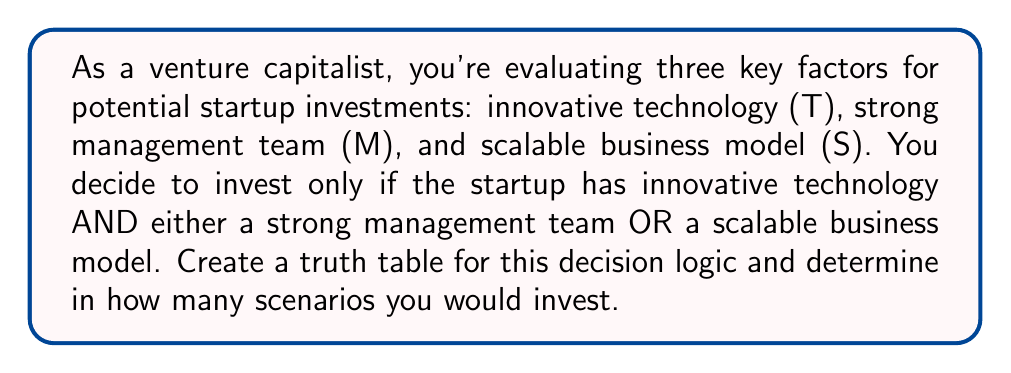Solve this math problem. Let's approach this step-by-step:

1) First, we need to translate the investment criteria into a Boolean expression:

   $T \land (M \lor S)$

   Where $\land$ represents AND, and $\lor$ represents OR.

2) Now, let's create a truth table. With three variables, we'll have $2^3 = 8$ rows:

   | T | M | S | T $\land$ (M $\lor$ S) |
   |---|---|---|------------------------|
   | 0 | 0 | 0 |                        |
   | 0 | 0 | 1 |                        |
   | 0 | 1 | 0 |                        |
   | 0 | 1 | 1 |                        |
   | 1 | 0 | 0 |                        |
   | 1 | 0 | 1 |                        |
   | 1 | 1 | 0 |                        |
   | 1 | 1 | 1 |                        |

3) Let's evaluate $(M \lor S)$ first:

   | T | M | S | (M $\lor$ S) | T $\land$ (M $\lor$ S) |
   |---|---|---|--------------|------------------------|
   | 0 | 0 | 0 |      0       |                        |
   | 0 | 0 | 1 |      1       |                        |
   | 0 | 1 | 0 |      1       |                        |
   | 0 | 1 | 1 |      1       |                        |
   | 1 | 0 | 0 |      0       |                        |
   | 1 | 0 | 1 |      1       |                        |
   | 1 | 1 | 0 |      1       |                        |
   | 1 | 1 | 1 |      1       |                        |

4) Now, let's complete the table by evaluating $T \land (M \lor S)$:

   | T | M | S | (M $\lor$ S) | T $\land$ (M $\lor$ S) |
   |---|---|---|--------------|------------------------|
   | 0 | 0 | 0 |      0       |           0            |
   | 0 | 0 | 1 |      1       |           0            |
   | 0 | 1 | 0 |      1       |           0            |
   | 0 | 1 | 1 |      1       |           0            |
   | 1 | 0 | 0 |      0       |           0            |
   | 1 | 0 | 1 |      1       |           1            |
   | 1 | 1 | 0 |      1       |           1            |
   | 1 | 1 | 1 |      1       |           1            |

5) Count the number of 1's in the final column. There are 3 scenarios where you would invest.
Answer: 3 scenarios 